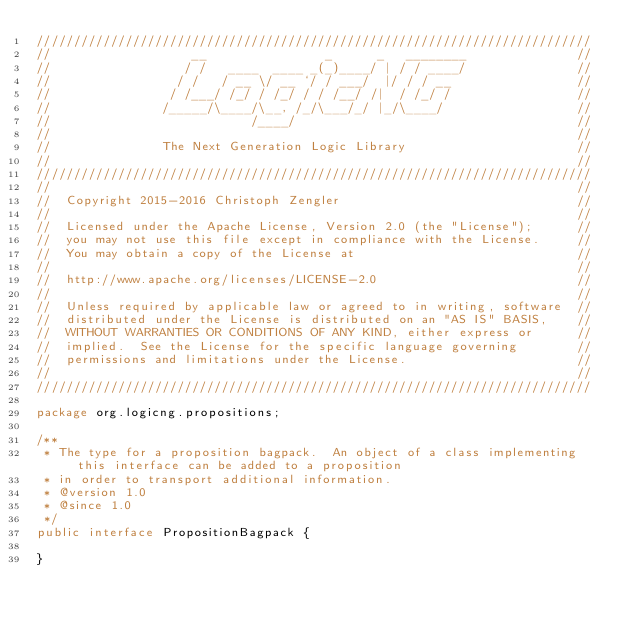Convert code to text. <code><loc_0><loc_0><loc_500><loc_500><_Java_>///////////////////////////////////////////////////////////////////////////
//                   __                _      _   ________               //
//                  / /   ____  ____ _(_)____/ | / / ____/               //
//                 / /   / __ \/ __ `/ / ___/  |/ / / __                 //
//                / /___/ /_/ / /_/ / / /__/ /|  / /_/ /                 //
//               /_____/\____/\__, /_/\___/_/ |_/\____/                  //
//                           /____/                                      //
//                                                                       //
//               The Next Generation Logic Library                       //
//                                                                       //
///////////////////////////////////////////////////////////////////////////
//                                                                       //
//  Copyright 2015-2016 Christoph Zengler                                //
//                                                                       //
//  Licensed under the Apache License, Version 2.0 (the "License");      //
//  you may not use this file except in compliance with the License.     //
//  You may obtain a copy of the License at                              //
//                                                                       //
//  http://www.apache.org/licenses/LICENSE-2.0                           //
//                                                                       //
//  Unless required by applicable law or agreed to in writing, software  //
//  distributed under the License is distributed on an "AS IS" BASIS,    //
//  WITHOUT WARRANTIES OR CONDITIONS OF ANY KIND, either express or      //
//  implied.  See the License for the specific language governing        //
//  permissions and limitations under the License.                       //
//                                                                       //
///////////////////////////////////////////////////////////////////////////

package org.logicng.propositions;

/**
 * The type for a proposition bagpack.  An object of a class implementing this interface can be added to a proposition
 * in order to transport additional information.
 * @version 1.0
 * @since 1.0
 */
public interface PropositionBagpack {

}
</code> 